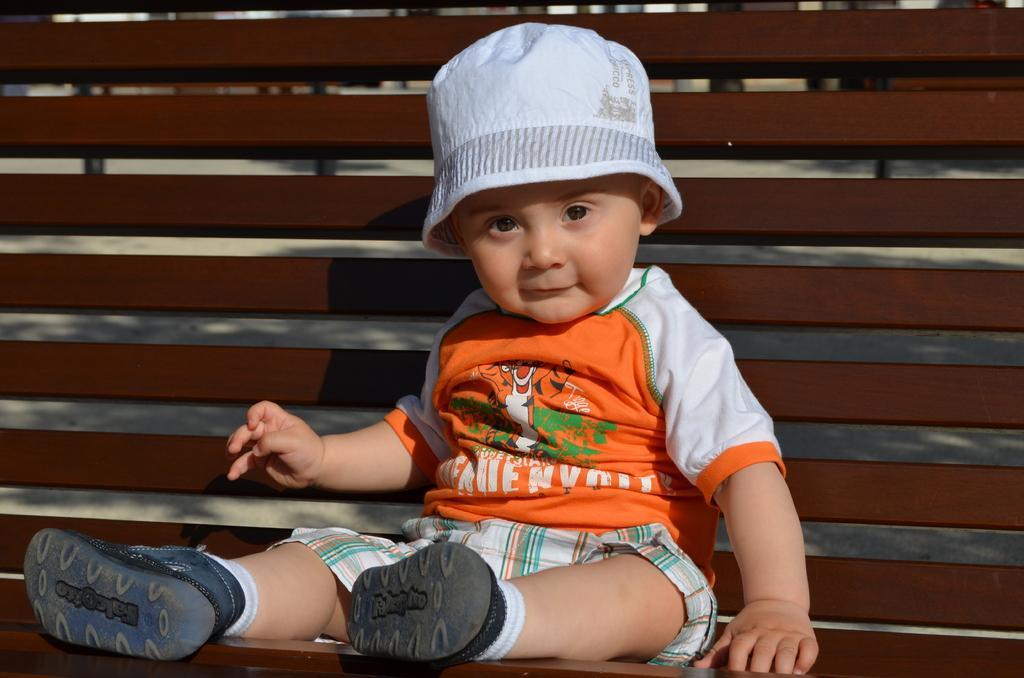Please provide a concise description of this image. In this image, we can see a kid wearing hat and sitting on the bench. 